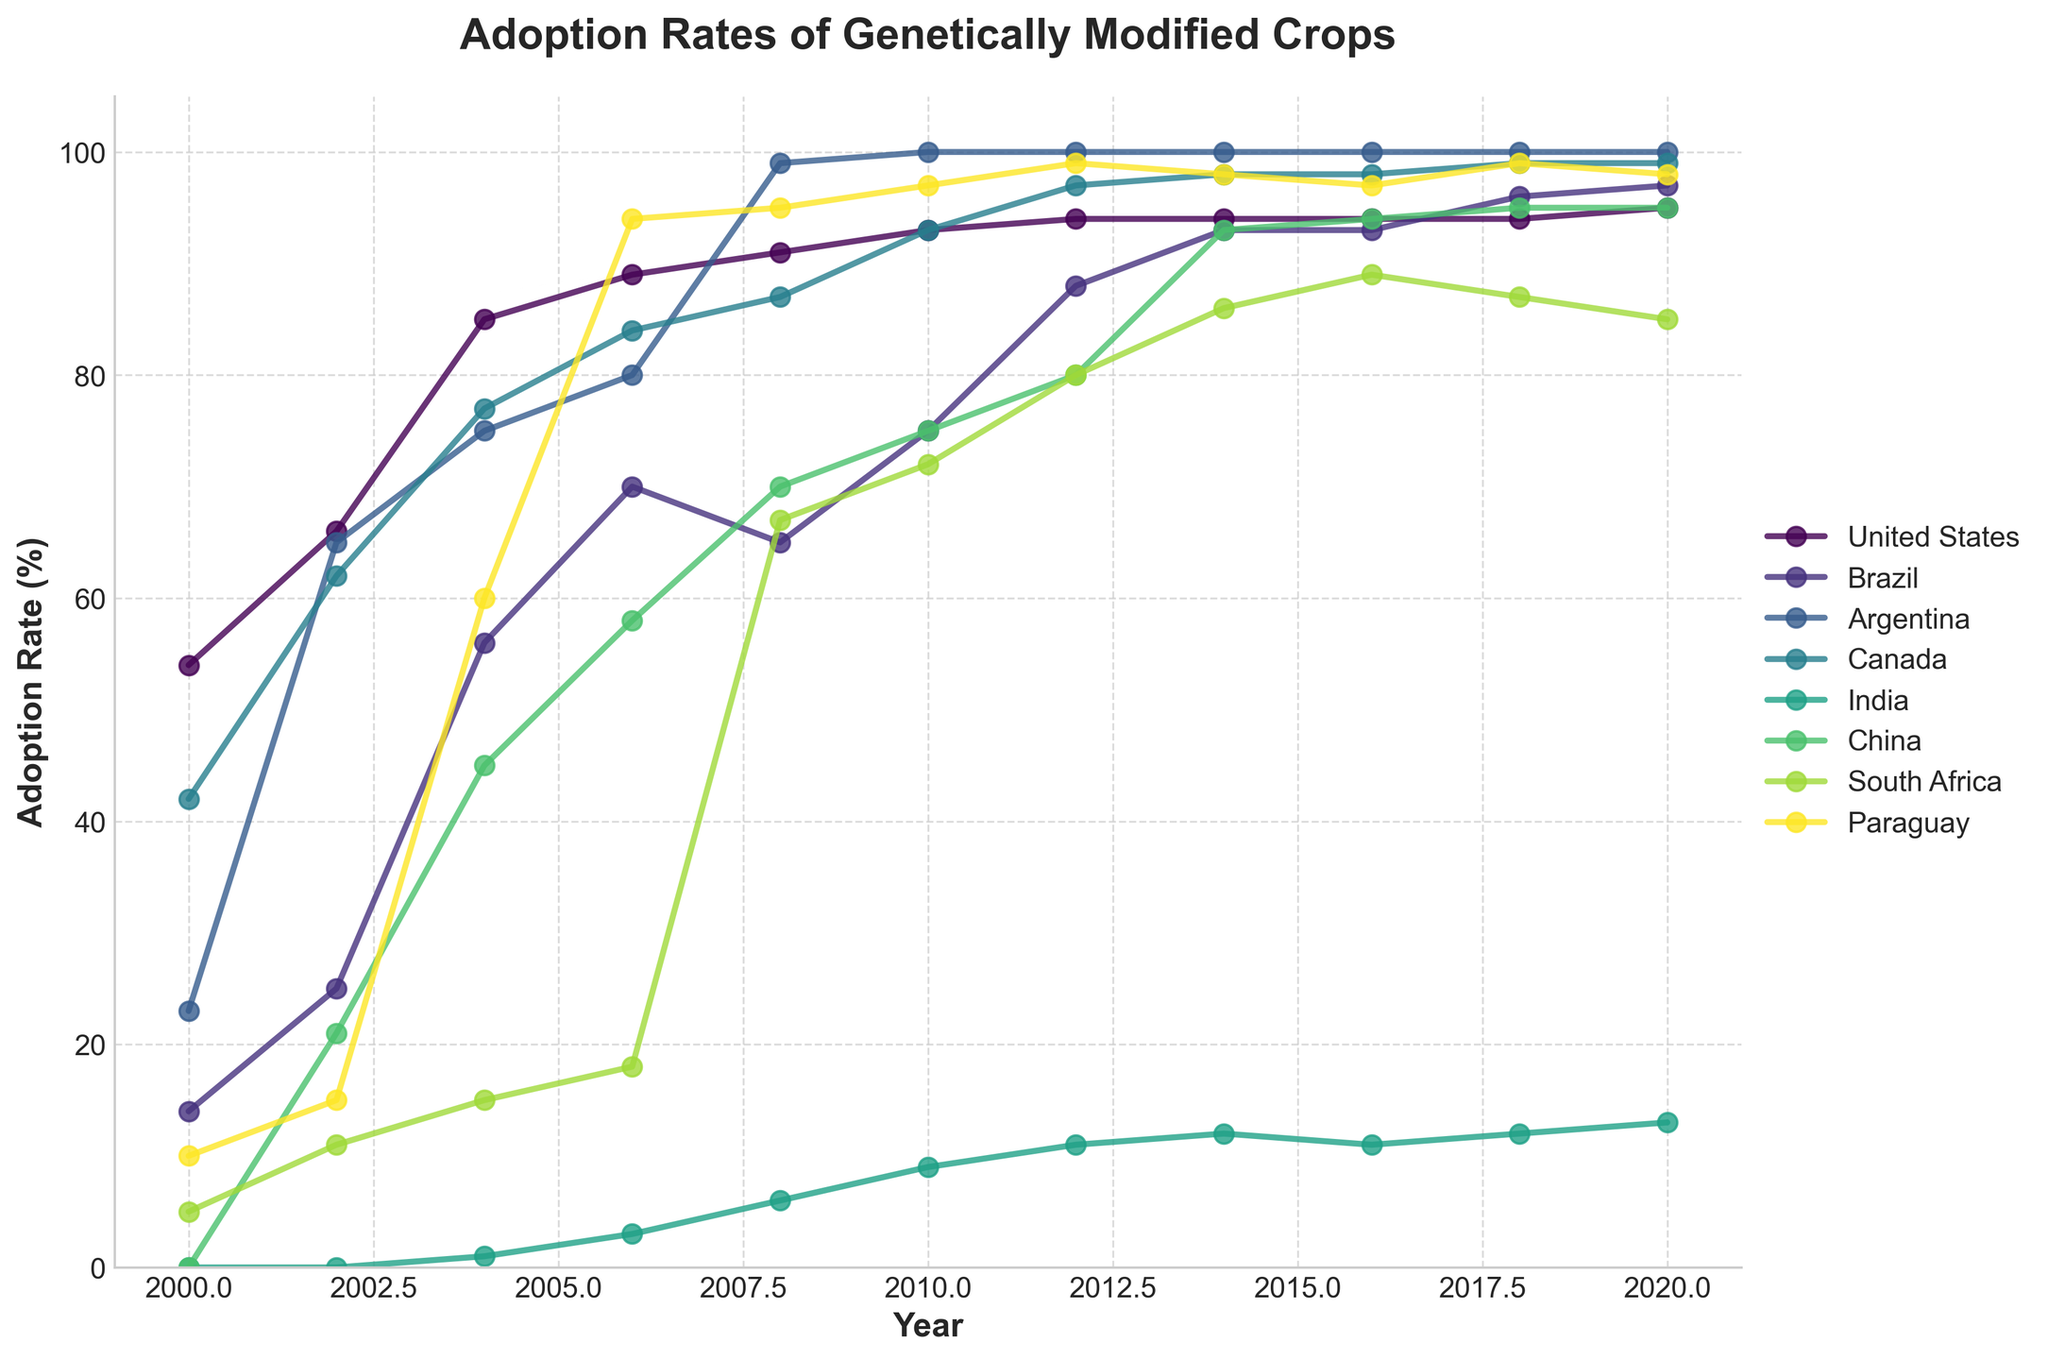What country shows the highest adoption rate of genetically modified crops by 2020? To find the highest adoption rate by 2020, we look at the y-values for 2020 and identify which country has the highest value. Argentina, with a rate of 100%, shows the highest adoption rate by 2020.
Answer: Argentina Which two countries had the same adoption rate in 2018? We check the y-values for all the countries in 2018 and compare them. Both China and India had an adoption rate of 95% in 2018.
Answer: China and India What was the average adoption rate across all countries in 2004? We sum up the adoption rates for all the countries in 2004 and divide by the number of countries. Sum = 85 + 56 + 75 + 77 + 1 + 45 + 15 + 60 = 414. There are 8 countries, so the average is 414 / 8 = 51.75%.
Answer: 51.75% Which country had the steepest increase in adoption rate between 2000 and 2002? We calculate the differences in adoption rates for each country between 2000 and 2002 and identify the country with the maximum difference. For example, the United States had an increase of 66 - 54 = 12, Brazil had 25 - 14 = 11, etc. Argentina had the steepest increase (65 - 23 = 42).
Answer: Argentina What is the difference in adoption rates between the United States and India in 2010? We subtract the adoption rate of India in 2010 from that of the United States in the same year. 93 (United States) - 9 (India) = 84.
Answer: 84 Which country had its adoption rate remain constant from 2016 to 2020? We look for a country whose adoption rate did not change from 2016 to 2020. Canada had a consistent adoption rate of 98% in both 2016 and 2020.
Answer: Canada How many years did it take for India's adoption rate to reach double digits? We identify the first year in which India's adoption rate was 10% or more. In 2004, India's rate was 1%, in 2006 it was 3%, in 2008 it was 6%, and by 2010 it was 9%. In 2012, it reached 11%, therefore it took from 2000 to 2012, totaling 12 years.
Answer: 12 years Which country had the lowest adoption rate in 2004, and what was it? We find the minimum y-value for all the countries in 2004. India had the lowest adoption rate in 2004 with a rate of 1%.
Answer: India What's the adoption rate trend of South Africa between 2008 and 2020? To observe the trend, we look at the values of South Africa from 2008 to 2020. The values are 67, 72, 80, 86, 89, 87, 85 respectively. The adoption rate generally increased over this period, though it fluctuated slightly after 2014.
Answer: Generally increasing 